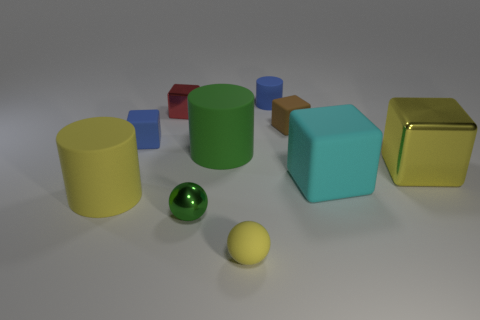There is a object that is the same color as the small rubber cylinder; what is its material?
Give a very brief answer. Rubber. The big metal block has what color?
Your answer should be compact. Yellow. How many things are big yellow cylinders or tiny blue matte objects?
Ensure brevity in your answer.  3. There is a red thing that is the same size as the brown rubber thing; what material is it?
Make the answer very short. Metal. There is a cylinder that is behind the brown thing; how big is it?
Make the answer very short. Small. What is the material of the small red cube?
Your answer should be compact. Metal. How many objects are either blue things in front of the brown thing or tiny blue rubber things that are in front of the red metal object?
Provide a succinct answer. 1. How many other objects are there of the same color as the tiny cylinder?
Make the answer very short. 1. Do the big cyan thing and the small rubber object that is to the left of the red block have the same shape?
Provide a succinct answer. Yes. Are there fewer small green balls that are behind the large cyan thing than big rubber cubes in front of the yellow cylinder?
Your response must be concise. No. 